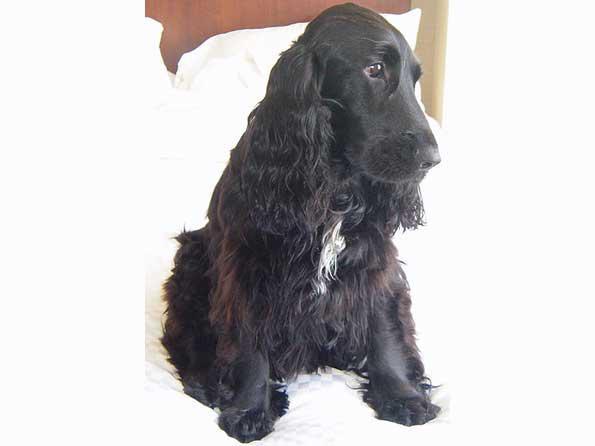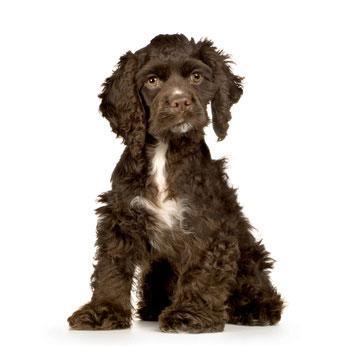The first image is the image on the left, the second image is the image on the right. Given the left and right images, does the statement "At least one of the dogs has its tongue handing out." hold true? Answer yes or no. No. The first image is the image on the left, the second image is the image on the right. Evaluate the accuracy of this statement regarding the images: "An image shows exactly one dog colored dark chocolate brown.". Is it true? Answer yes or no. Yes. 